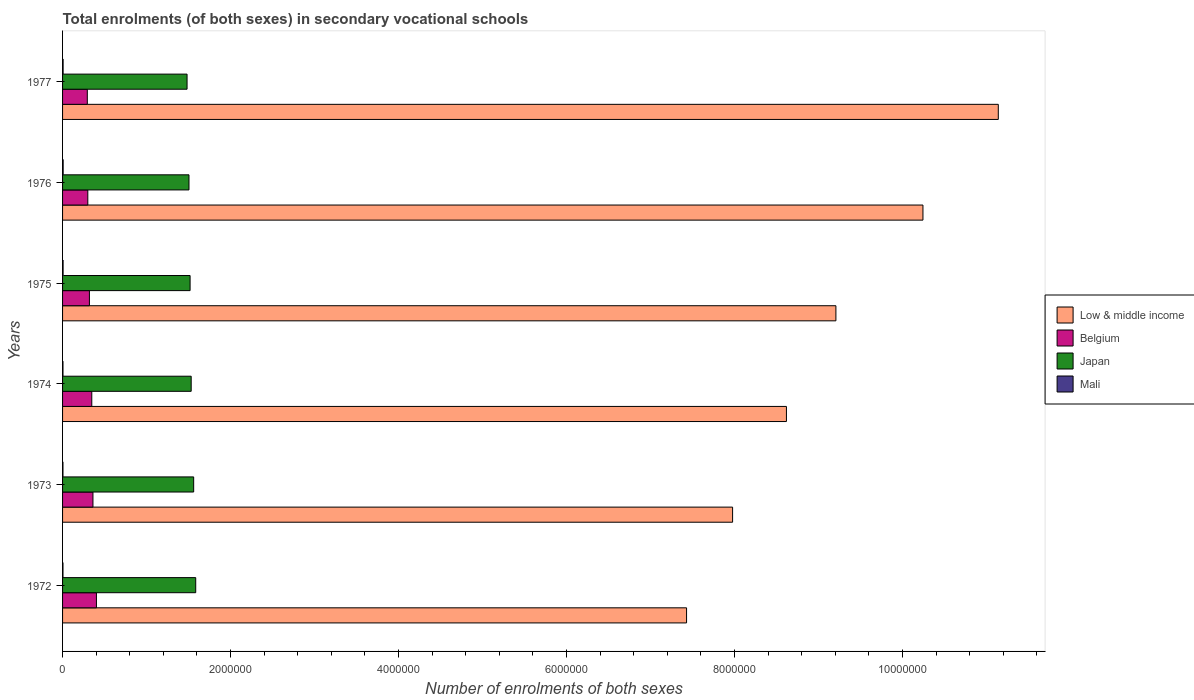How many different coloured bars are there?
Your answer should be very brief. 4. How many groups of bars are there?
Make the answer very short. 6. Are the number of bars per tick equal to the number of legend labels?
Offer a very short reply. Yes. How many bars are there on the 2nd tick from the bottom?
Provide a short and direct response. 4. What is the label of the 1st group of bars from the top?
Ensure brevity in your answer.  1977. In how many cases, is the number of bars for a given year not equal to the number of legend labels?
Ensure brevity in your answer.  0. What is the number of enrolments in secondary schools in Belgium in 1976?
Provide a succinct answer. 3.01e+05. Across all years, what is the maximum number of enrolments in secondary schools in Low & middle income?
Provide a succinct answer. 1.11e+07. Across all years, what is the minimum number of enrolments in secondary schools in Mali?
Make the answer very short. 4811. In which year was the number of enrolments in secondary schools in Low & middle income minimum?
Provide a short and direct response. 1972. What is the total number of enrolments in secondary schools in Low & middle income in the graph?
Make the answer very short. 5.46e+07. What is the difference between the number of enrolments in secondary schools in Mali in 1972 and that in 1973?
Your answer should be compact. 201. What is the difference between the number of enrolments in secondary schools in Mali in 1975 and the number of enrolments in secondary schools in Low & middle income in 1976?
Make the answer very short. -1.02e+07. What is the average number of enrolments in secondary schools in Belgium per year?
Provide a succinct answer. 3.38e+05. In the year 1972, what is the difference between the number of enrolments in secondary schools in Belgium and number of enrolments in secondary schools in Mali?
Offer a terse response. 3.98e+05. In how many years, is the number of enrolments in secondary schools in Japan greater than 9200000 ?
Give a very brief answer. 0. What is the ratio of the number of enrolments in secondary schools in Japan in 1972 to that in 1977?
Your answer should be compact. 1.07. Is the number of enrolments in secondary schools in Belgium in 1972 less than that in 1977?
Ensure brevity in your answer.  No. What is the difference between the highest and the second highest number of enrolments in secondary schools in Belgium?
Make the answer very short. 4.15e+04. What is the difference between the highest and the lowest number of enrolments in secondary schools in Low & middle income?
Your answer should be compact. 3.71e+06. Is the sum of the number of enrolments in secondary schools in Japan in 1975 and 1976 greater than the maximum number of enrolments in secondary schools in Low & middle income across all years?
Your response must be concise. No. What does the 1st bar from the top in 1972 represents?
Provide a short and direct response. Mali. Are all the bars in the graph horizontal?
Your response must be concise. Yes. What is the difference between two consecutive major ticks on the X-axis?
Keep it short and to the point. 2.00e+06. Are the values on the major ticks of X-axis written in scientific E-notation?
Give a very brief answer. No. Does the graph contain grids?
Offer a terse response. No. What is the title of the graph?
Make the answer very short. Total enrolments (of both sexes) in secondary vocational schools. Does "Mali" appear as one of the legend labels in the graph?
Provide a succinct answer. Yes. What is the label or title of the X-axis?
Ensure brevity in your answer.  Number of enrolments of both sexes. What is the Number of enrolments of both sexes of Low & middle income in 1972?
Your response must be concise. 7.43e+06. What is the Number of enrolments of both sexes of Belgium in 1972?
Ensure brevity in your answer.  4.03e+05. What is the Number of enrolments of both sexes in Japan in 1972?
Offer a very short reply. 1.59e+06. What is the Number of enrolments of both sexes of Mali in 1972?
Keep it short and to the point. 5012. What is the Number of enrolments of both sexes of Low & middle income in 1973?
Your answer should be very brief. 7.98e+06. What is the Number of enrolments of both sexes of Belgium in 1973?
Your answer should be very brief. 3.62e+05. What is the Number of enrolments of both sexes of Japan in 1973?
Your answer should be very brief. 1.56e+06. What is the Number of enrolments of both sexes of Mali in 1973?
Your answer should be compact. 4811. What is the Number of enrolments of both sexes in Low & middle income in 1974?
Your answer should be compact. 8.62e+06. What is the Number of enrolments of both sexes in Belgium in 1974?
Offer a very short reply. 3.48e+05. What is the Number of enrolments of both sexes in Japan in 1974?
Your response must be concise. 1.53e+06. What is the Number of enrolments of both sexes of Mali in 1974?
Your response must be concise. 4930. What is the Number of enrolments of both sexes of Low & middle income in 1975?
Provide a short and direct response. 9.21e+06. What is the Number of enrolments of both sexes in Belgium in 1975?
Make the answer very short. 3.20e+05. What is the Number of enrolments of both sexes of Japan in 1975?
Your response must be concise. 1.52e+06. What is the Number of enrolments of both sexes of Mali in 1975?
Your answer should be compact. 6366. What is the Number of enrolments of both sexes in Low & middle income in 1976?
Provide a short and direct response. 1.02e+07. What is the Number of enrolments of both sexes of Belgium in 1976?
Your response must be concise. 3.01e+05. What is the Number of enrolments of both sexes in Japan in 1976?
Provide a short and direct response. 1.51e+06. What is the Number of enrolments of both sexes of Mali in 1976?
Provide a succinct answer. 6956. What is the Number of enrolments of both sexes of Low & middle income in 1977?
Ensure brevity in your answer.  1.11e+07. What is the Number of enrolments of both sexes of Belgium in 1977?
Your answer should be very brief. 2.95e+05. What is the Number of enrolments of both sexes of Japan in 1977?
Your answer should be very brief. 1.48e+06. What is the Number of enrolments of both sexes in Mali in 1977?
Your response must be concise. 6514. Across all years, what is the maximum Number of enrolments of both sexes of Low & middle income?
Your answer should be very brief. 1.11e+07. Across all years, what is the maximum Number of enrolments of both sexes of Belgium?
Provide a succinct answer. 4.03e+05. Across all years, what is the maximum Number of enrolments of both sexes in Japan?
Your response must be concise. 1.59e+06. Across all years, what is the maximum Number of enrolments of both sexes in Mali?
Ensure brevity in your answer.  6956. Across all years, what is the minimum Number of enrolments of both sexes in Low & middle income?
Provide a succinct answer. 7.43e+06. Across all years, what is the minimum Number of enrolments of both sexes in Belgium?
Offer a very short reply. 2.95e+05. Across all years, what is the minimum Number of enrolments of both sexes of Japan?
Make the answer very short. 1.48e+06. Across all years, what is the minimum Number of enrolments of both sexes in Mali?
Offer a very short reply. 4811. What is the total Number of enrolments of both sexes of Low & middle income in the graph?
Offer a terse response. 5.46e+07. What is the total Number of enrolments of both sexes of Belgium in the graph?
Offer a very short reply. 2.03e+06. What is the total Number of enrolments of both sexes of Japan in the graph?
Give a very brief answer. 9.18e+06. What is the total Number of enrolments of both sexes of Mali in the graph?
Ensure brevity in your answer.  3.46e+04. What is the difference between the Number of enrolments of both sexes in Low & middle income in 1972 and that in 1973?
Offer a very short reply. -5.48e+05. What is the difference between the Number of enrolments of both sexes in Belgium in 1972 and that in 1973?
Provide a short and direct response. 4.15e+04. What is the difference between the Number of enrolments of both sexes of Japan in 1972 and that in 1973?
Offer a very short reply. 2.44e+04. What is the difference between the Number of enrolments of both sexes in Mali in 1972 and that in 1973?
Offer a terse response. 201. What is the difference between the Number of enrolments of both sexes of Low & middle income in 1972 and that in 1974?
Make the answer very short. -1.19e+06. What is the difference between the Number of enrolments of both sexes in Belgium in 1972 and that in 1974?
Your answer should be compact. 5.54e+04. What is the difference between the Number of enrolments of both sexes of Japan in 1972 and that in 1974?
Keep it short and to the point. 5.41e+04. What is the difference between the Number of enrolments of both sexes of Mali in 1972 and that in 1974?
Provide a succinct answer. 82. What is the difference between the Number of enrolments of both sexes in Low & middle income in 1972 and that in 1975?
Your answer should be very brief. -1.78e+06. What is the difference between the Number of enrolments of both sexes in Belgium in 1972 and that in 1975?
Give a very brief answer. 8.36e+04. What is the difference between the Number of enrolments of both sexes in Japan in 1972 and that in 1975?
Ensure brevity in your answer.  6.70e+04. What is the difference between the Number of enrolments of both sexes in Mali in 1972 and that in 1975?
Ensure brevity in your answer.  -1354. What is the difference between the Number of enrolments of both sexes in Low & middle income in 1972 and that in 1976?
Provide a short and direct response. -2.81e+06. What is the difference between the Number of enrolments of both sexes in Belgium in 1972 and that in 1976?
Your answer should be very brief. 1.03e+05. What is the difference between the Number of enrolments of both sexes of Japan in 1972 and that in 1976?
Offer a very short reply. 8.02e+04. What is the difference between the Number of enrolments of both sexes in Mali in 1972 and that in 1976?
Keep it short and to the point. -1944. What is the difference between the Number of enrolments of both sexes of Low & middle income in 1972 and that in 1977?
Your answer should be very brief. -3.71e+06. What is the difference between the Number of enrolments of both sexes of Belgium in 1972 and that in 1977?
Ensure brevity in your answer.  1.09e+05. What is the difference between the Number of enrolments of both sexes in Japan in 1972 and that in 1977?
Make the answer very short. 1.03e+05. What is the difference between the Number of enrolments of both sexes in Mali in 1972 and that in 1977?
Ensure brevity in your answer.  -1502. What is the difference between the Number of enrolments of both sexes of Low & middle income in 1973 and that in 1974?
Keep it short and to the point. -6.41e+05. What is the difference between the Number of enrolments of both sexes in Belgium in 1973 and that in 1974?
Keep it short and to the point. 1.40e+04. What is the difference between the Number of enrolments of both sexes in Japan in 1973 and that in 1974?
Ensure brevity in your answer.  2.97e+04. What is the difference between the Number of enrolments of both sexes of Mali in 1973 and that in 1974?
Your answer should be compact. -119. What is the difference between the Number of enrolments of both sexes of Low & middle income in 1973 and that in 1975?
Offer a terse response. -1.23e+06. What is the difference between the Number of enrolments of both sexes of Belgium in 1973 and that in 1975?
Offer a terse response. 4.21e+04. What is the difference between the Number of enrolments of both sexes of Japan in 1973 and that in 1975?
Offer a terse response. 4.26e+04. What is the difference between the Number of enrolments of both sexes of Mali in 1973 and that in 1975?
Provide a short and direct response. -1555. What is the difference between the Number of enrolments of both sexes of Low & middle income in 1973 and that in 1976?
Ensure brevity in your answer.  -2.27e+06. What is the difference between the Number of enrolments of both sexes of Belgium in 1973 and that in 1976?
Offer a very short reply. 6.13e+04. What is the difference between the Number of enrolments of both sexes in Japan in 1973 and that in 1976?
Provide a succinct answer. 5.59e+04. What is the difference between the Number of enrolments of both sexes in Mali in 1973 and that in 1976?
Ensure brevity in your answer.  -2145. What is the difference between the Number of enrolments of both sexes of Low & middle income in 1973 and that in 1977?
Ensure brevity in your answer.  -3.16e+06. What is the difference between the Number of enrolments of both sexes in Belgium in 1973 and that in 1977?
Provide a short and direct response. 6.72e+04. What is the difference between the Number of enrolments of both sexes in Japan in 1973 and that in 1977?
Offer a terse response. 7.88e+04. What is the difference between the Number of enrolments of both sexes of Mali in 1973 and that in 1977?
Ensure brevity in your answer.  -1703. What is the difference between the Number of enrolments of both sexes of Low & middle income in 1974 and that in 1975?
Your answer should be compact. -5.89e+05. What is the difference between the Number of enrolments of both sexes of Belgium in 1974 and that in 1975?
Ensure brevity in your answer.  2.81e+04. What is the difference between the Number of enrolments of both sexes of Japan in 1974 and that in 1975?
Give a very brief answer. 1.29e+04. What is the difference between the Number of enrolments of both sexes of Mali in 1974 and that in 1975?
Keep it short and to the point. -1436. What is the difference between the Number of enrolments of both sexes in Low & middle income in 1974 and that in 1976?
Ensure brevity in your answer.  -1.63e+06. What is the difference between the Number of enrolments of both sexes in Belgium in 1974 and that in 1976?
Give a very brief answer. 4.73e+04. What is the difference between the Number of enrolments of both sexes in Japan in 1974 and that in 1976?
Offer a very short reply. 2.62e+04. What is the difference between the Number of enrolments of both sexes in Mali in 1974 and that in 1976?
Ensure brevity in your answer.  -2026. What is the difference between the Number of enrolments of both sexes in Low & middle income in 1974 and that in 1977?
Make the answer very short. -2.52e+06. What is the difference between the Number of enrolments of both sexes of Belgium in 1974 and that in 1977?
Your answer should be compact. 5.32e+04. What is the difference between the Number of enrolments of both sexes of Japan in 1974 and that in 1977?
Keep it short and to the point. 4.91e+04. What is the difference between the Number of enrolments of both sexes of Mali in 1974 and that in 1977?
Ensure brevity in your answer.  -1584. What is the difference between the Number of enrolments of both sexes of Low & middle income in 1975 and that in 1976?
Ensure brevity in your answer.  -1.04e+06. What is the difference between the Number of enrolments of both sexes in Belgium in 1975 and that in 1976?
Give a very brief answer. 1.92e+04. What is the difference between the Number of enrolments of both sexes in Japan in 1975 and that in 1976?
Offer a terse response. 1.33e+04. What is the difference between the Number of enrolments of both sexes in Mali in 1975 and that in 1976?
Keep it short and to the point. -590. What is the difference between the Number of enrolments of both sexes of Low & middle income in 1975 and that in 1977?
Ensure brevity in your answer.  -1.93e+06. What is the difference between the Number of enrolments of both sexes in Belgium in 1975 and that in 1977?
Your response must be concise. 2.51e+04. What is the difference between the Number of enrolments of both sexes of Japan in 1975 and that in 1977?
Your answer should be compact. 3.62e+04. What is the difference between the Number of enrolments of both sexes in Mali in 1975 and that in 1977?
Offer a very short reply. -148. What is the difference between the Number of enrolments of both sexes of Low & middle income in 1976 and that in 1977?
Ensure brevity in your answer.  -8.97e+05. What is the difference between the Number of enrolments of both sexes of Belgium in 1976 and that in 1977?
Provide a succinct answer. 5933. What is the difference between the Number of enrolments of both sexes of Japan in 1976 and that in 1977?
Provide a short and direct response. 2.29e+04. What is the difference between the Number of enrolments of both sexes in Mali in 1976 and that in 1977?
Your answer should be compact. 442. What is the difference between the Number of enrolments of both sexes of Low & middle income in 1972 and the Number of enrolments of both sexes of Belgium in 1973?
Your response must be concise. 7.07e+06. What is the difference between the Number of enrolments of both sexes in Low & middle income in 1972 and the Number of enrolments of both sexes in Japan in 1973?
Offer a terse response. 5.87e+06. What is the difference between the Number of enrolments of both sexes of Low & middle income in 1972 and the Number of enrolments of both sexes of Mali in 1973?
Keep it short and to the point. 7.42e+06. What is the difference between the Number of enrolments of both sexes in Belgium in 1972 and the Number of enrolments of both sexes in Japan in 1973?
Offer a terse response. -1.16e+06. What is the difference between the Number of enrolments of both sexes in Belgium in 1972 and the Number of enrolments of both sexes in Mali in 1973?
Give a very brief answer. 3.98e+05. What is the difference between the Number of enrolments of both sexes of Japan in 1972 and the Number of enrolments of both sexes of Mali in 1973?
Your answer should be very brief. 1.58e+06. What is the difference between the Number of enrolments of both sexes in Low & middle income in 1972 and the Number of enrolments of both sexes in Belgium in 1974?
Keep it short and to the point. 7.08e+06. What is the difference between the Number of enrolments of both sexes of Low & middle income in 1972 and the Number of enrolments of both sexes of Japan in 1974?
Offer a very short reply. 5.90e+06. What is the difference between the Number of enrolments of both sexes of Low & middle income in 1972 and the Number of enrolments of both sexes of Mali in 1974?
Your answer should be very brief. 7.42e+06. What is the difference between the Number of enrolments of both sexes of Belgium in 1972 and the Number of enrolments of both sexes of Japan in 1974?
Provide a short and direct response. -1.13e+06. What is the difference between the Number of enrolments of both sexes in Belgium in 1972 and the Number of enrolments of both sexes in Mali in 1974?
Your response must be concise. 3.98e+05. What is the difference between the Number of enrolments of both sexes in Japan in 1972 and the Number of enrolments of both sexes in Mali in 1974?
Your answer should be very brief. 1.58e+06. What is the difference between the Number of enrolments of both sexes of Low & middle income in 1972 and the Number of enrolments of both sexes of Belgium in 1975?
Provide a succinct answer. 7.11e+06. What is the difference between the Number of enrolments of both sexes in Low & middle income in 1972 and the Number of enrolments of both sexes in Japan in 1975?
Ensure brevity in your answer.  5.91e+06. What is the difference between the Number of enrolments of both sexes in Low & middle income in 1972 and the Number of enrolments of both sexes in Mali in 1975?
Give a very brief answer. 7.42e+06. What is the difference between the Number of enrolments of both sexes in Belgium in 1972 and the Number of enrolments of both sexes in Japan in 1975?
Ensure brevity in your answer.  -1.12e+06. What is the difference between the Number of enrolments of both sexes in Belgium in 1972 and the Number of enrolments of both sexes in Mali in 1975?
Provide a succinct answer. 3.97e+05. What is the difference between the Number of enrolments of both sexes in Japan in 1972 and the Number of enrolments of both sexes in Mali in 1975?
Ensure brevity in your answer.  1.58e+06. What is the difference between the Number of enrolments of both sexes of Low & middle income in 1972 and the Number of enrolments of both sexes of Belgium in 1976?
Offer a terse response. 7.13e+06. What is the difference between the Number of enrolments of both sexes in Low & middle income in 1972 and the Number of enrolments of both sexes in Japan in 1976?
Keep it short and to the point. 5.92e+06. What is the difference between the Number of enrolments of both sexes of Low & middle income in 1972 and the Number of enrolments of both sexes of Mali in 1976?
Your answer should be compact. 7.42e+06. What is the difference between the Number of enrolments of both sexes in Belgium in 1972 and the Number of enrolments of both sexes in Japan in 1976?
Give a very brief answer. -1.10e+06. What is the difference between the Number of enrolments of both sexes of Belgium in 1972 and the Number of enrolments of both sexes of Mali in 1976?
Make the answer very short. 3.96e+05. What is the difference between the Number of enrolments of both sexes in Japan in 1972 and the Number of enrolments of both sexes in Mali in 1976?
Offer a very short reply. 1.58e+06. What is the difference between the Number of enrolments of both sexes of Low & middle income in 1972 and the Number of enrolments of both sexes of Belgium in 1977?
Your answer should be compact. 7.13e+06. What is the difference between the Number of enrolments of both sexes of Low & middle income in 1972 and the Number of enrolments of both sexes of Japan in 1977?
Keep it short and to the point. 5.95e+06. What is the difference between the Number of enrolments of both sexes of Low & middle income in 1972 and the Number of enrolments of both sexes of Mali in 1977?
Ensure brevity in your answer.  7.42e+06. What is the difference between the Number of enrolments of both sexes in Belgium in 1972 and the Number of enrolments of both sexes in Japan in 1977?
Ensure brevity in your answer.  -1.08e+06. What is the difference between the Number of enrolments of both sexes in Belgium in 1972 and the Number of enrolments of both sexes in Mali in 1977?
Make the answer very short. 3.97e+05. What is the difference between the Number of enrolments of both sexes of Japan in 1972 and the Number of enrolments of both sexes of Mali in 1977?
Keep it short and to the point. 1.58e+06. What is the difference between the Number of enrolments of both sexes of Low & middle income in 1973 and the Number of enrolments of both sexes of Belgium in 1974?
Your response must be concise. 7.63e+06. What is the difference between the Number of enrolments of both sexes in Low & middle income in 1973 and the Number of enrolments of both sexes in Japan in 1974?
Provide a succinct answer. 6.45e+06. What is the difference between the Number of enrolments of both sexes in Low & middle income in 1973 and the Number of enrolments of both sexes in Mali in 1974?
Your answer should be very brief. 7.97e+06. What is the difference between the Number of enrolments of both sexes of Belgium in 1973 and the Number of enrolments of both sexes of Japan in 1974?
Your answer should be very brief. -1.17e+06. What is the difference between the Number of enrolments of both sexes of Belgium in 1973 and the Number of enrolments of both sexes of Mali in 1974?
Offer a terse response. 3.57e+05. What is the difference between the Number of enrolments of both sexes of Japan in 1973 and the Number of enrolments of both sexes of Mali in 1974?
Keep it short and to the point. 1.56e+06. What is the difference between the Number of enrolments of both sexes in Low & middle income in 1973 and the Number of enrolments of both sexes in Belgium in 1975?
Offer a very short reply. 7.66e+06. What is the difference between the Number of enrolments of both sexes in Low & middle income in 1973 and the Number of enrolments of both sexes in Japan in 1975?
Your response must be concise. 6.46e+06. What is the difference between the Number of enrolments of both sexes of Low & middle income in 1973 and the Number of enrolments of both sexes of Mali in 1975?
Your answer should be very brief. 7.97e+06. What is the difference between the Number of enrolments of both sexes of Belgium in 1973 and the Number of enrolments of both sexes of Japan in 1975?
Give a very brief answer. -1.16e+06. What is the difference between the Number of enrolments of both sexes of Belgium in 1973 and the Number of enrolments of both sexes of Mali in 1975?
Offer a very short reply. 3.55e+05. What is the difference between the Number of enrolments of both sexes of Japan in 1973 and the Number of enrolments of both sexes of Mali in 1975?
Your answer should be compact. 1.55e+06. What is the difference between the Number of enrolments of both sexes in Low & middle income in 1973 and the Number of enrolments of both sexes in Belgium in 1976?
Offer a terse response. 7.68e+06. What is the difference between the Number of enrolments of both sexes of Low & middle income in 1973 and the Number of enrolments of both sexes of Japan in 1976?
Offer a very short reply. 6.47e+06. What is the difference between the Number of enrolments of both sexes in Low & middle income in 1973 and the Number of enrolments of both sexes in Mali in 1976?
Provide a short and direct response. 7.97e+06. What is the difference between the Number of enrolments of both sexes of Belgium in 1973 and the Number of enrolments of both sexes of Japan in 1976?
Give a very brief answer. -1.14e+06. What is the difference between the Number of enrolments of both sexes in Belgium in 1973 and the Number of enrolments of both sexes in Mali in 1976?
Offer a terse response. 3.55e+05. What is the difference between the Number of enrolments of both sexes in Japan in 1973 and the Number of enrolments of both sexes in Mali in 1976?
Offer a very short reply. 1.55e+06. What is the difference between the Number of enrolments of both sexes of Low & middle income in 1973 and the Number of enrolments of both sexes of Belgium in 1977?
Provide a short and direct response. 7.68e+06. What is the difference between the Number of enrolments of both sexes of Low & middle income in 1973 and the Number of enrolments of both sexes of Japan in 1977?
Ensure brevity in your answer.  6.49e+06. What is the difference between the Number of enrolments of both sexes in Low & middle income in 1973 and the Number of enrolments of both sexes in Mali in 1977?
Offer a very short reply. 7.97e+06. What is the difference between the Number of enrolments of both sexes of Belgium in 1973 and the Number of enrolments of both sexes of Japan in 1977?
Keep it short and to the point. -1.12e+06. What is the difference between the Number of enrolments of both sexes in Belgium in 1973 and the Number of enrolments of both sexes in Mali in 1977?
Offer a terse response. 3.55e+05. What is the difference between the Number of enrolments of both sexes in Japan in 1973 and the Number of enrolments of both sexes in Mali in 1977?
Provide a short and direct response. 1.55e+06. What is the difference between the Number of enrolments of both sexes in Low & middle income in 1974 and the Number of enrolments of both sexes in Belgium in 1975?
Provide a succinct answer. 8.30e+06. What is the difference between the Number of enrolments of both sexes in Low & middle income in 1974 and the Number of enrolments of both sexes in Japan in 1975?
Offer a very short reply. 7.10e+06. What is the difference between the Number of enrolments of both sexes of Low & middle income in 1974 and the Number of enrolments of both sexes of Mali in 1975?
Your response must be concise. 8.61e+06. What is the difference between the Number of enrolments of both sexes in Belgium in 1974 and the Number of enrolments of both sexes in Japan in 1975?
Make the answer very short. -1.17e+06. What is the difference between the Number of enrolments of both sexes of Belgium in 1974 and the Number of enrolments of both sexes of Mali in 1975?
Your response must be concise. 3.41e+05. What is the difference between the Number of enrolments of both sexes of Japan in 1974 and the Number of enrolments of both sexes of Mali in 1975?
Give a very brief answer. 1.52e+06. What is the difference between the Number of enrolments of both sexes in Low & middle income in 1974 and the Number of enrolments of both sexes in Belgium in 1976?
Provide a short and direct response. 8.32e+06. What is the difference between the Number of enrolments of both sexes of Low & middle income in 1974 and the Number of enrolments of both sexes of Japan in 1976?
Your answer should be compact. 7.11e+06. What is the difference between the Number of enrolments of both sexes of Low & middle income in 1974 and the Number of enrolments of both sexes of Mali in 1976?
Make the answer very short. 8.61e+06. What is the difference between the Number of enrolments of both sexes in Belgium in 1974 and the Number of enrolments of both sexes in Japan in 1976?
Your answer should be very brief. -1.16e+06. What is the difference between the Number of enrolments of both sexes of Belgium in 1974 and the Number of enrolments of both sexes of Mali in 1976?
Keep it short and to the point. 3.41e+05. What is the difference between the Number of enrolments of both sexes in Japan in 1974 and the Number of enrolments of both sexes in Mali in 1976?
Offer a very short reply. 1.52e+06. What is the difference between the Number of enrolments of both sexes of Low & middle income in 1974 and the Number of enrolments of both sexes of Belgium in 1977?
Make the answer very short. 8.32e+06. What is the difference between the Number of enrolments of both sexes in Low & middle income in 1974 and the Number of enrolments of both sexes in Japan in 1977?
Ensure brevity in your answer.  7.14e+06. What is the difference between the Number of enrolments of both sexes of Low & middle income in 1974 and the Number of enrolments of both sexes of Mali in 1977?
Your answer should be compact. 8.61e+06. What is the difference between the Number of enrolments of both sexes of Belgium in 1974 and the Number of enrolments of both sexes of Japan in 1977?
Your response must be concise. -1.13e+06. What is the difference between the Number of enrolments of both sexes in Belgium in 1974 and the Number of enrolments of both sexes in Mali in 1977?
Your answer should be compact. 3.41e+05. What is the difference between the Number of enrolments of both sexes of Japan in 1974 and the Number of enrolments of both sexes of Mali in 1977?
Offer a terse response. 1.52e+06. What is the difference between the Number of enrolments of both sexes in Low & middle income in 1975 and the Number of enrolments of both sexes in Belgium in 1976?
Offer a very short reply. 8.91e+06. What is the difference between the Number of enrolments of both sexes of Low & middle income in 1975 and the Number of enrolments of both sexes of Japan in 1976?
Ensure brevity in your answer.  7.70e+06. What is the difference between the Number of enrolments of both sexes in Low & middle income in 1975 and the Number of enrolments of both sexes in Mali in 1976?
Give a very brief answer. 9.20e+06. What is the difference between the Number of enrolments of both sexes in Belgium in 1975 and the Number of enrolments of both sexes in Japan in 1976?
Provide a succinct answer. -1.19e+06. What is the difference between the Number of enrolments of both sexes in Belgium in 1975 and the Number of enrolments of both sexes in Mali in 1976?
Provide a succinct answer. 3.13e+05. What is the difference between the Number of enrolments of both sexes of Japan in 1975 and the Number of enrolments of both sexes of Mali in 1976?
Keep it short and to the point. 1.51e+06. What is the difference between the Number of enrolments of both sexes in Low & middle income in 1975 and the Number of enrolments of both sexes in Belgium in 1977?
Provide a short and direct response. 8.91e+06. What is the difference between the Number of enrolments of both sexes of Low & middle income in 1975 and the Number of enrolments of both sexes of Japan in 1977?
Keep it short and to the point. 7.72e+06. What is the difference between the Number of enrolments of both sexes of Low & middle income in 1975 and the Number of enrolments of both sexes of Mali in 1977?
Give a very brief answer. 9.20e+06. What is the difference between the Number of enrolments of both sexes in Belgium in 1975 and the Number of enrolments of both sexes in Japan in 1977?
Provide a succinct answer. -1.16e+06. What is the difference between the Number of enrolments of both sexes of Belgium in 1975 and the Number of enrolments of both sexes of Mali in 1977?
Your response must be concise. 3.13e+05. What is the difference between the Number of enrolments of both sexes in Japan in 1975 and the Number of enrolments of both sexes in Mali in 1977?
Provide a succinct answer. 1.51e+06. What is the difference between the Number of enrolments of both sexes of Low & middle income in 1976 and the Number of enrolments of both sexes of Belgium in 1977?
Provide a succinct answer. 9.95e+06. What is the difference between the Number of enrolments of both sexes in Low & middle income in 1976 and the Number of enrolments of both sexes in Japan in 1977?
Offer a terse response. 8.76e+06. What is the difference between the Number of enrolments of both sexes of Low & middle income in 1976 and the Number of enrolments of both sexes of Mali in 1977?
Offer a very short reply. 1.02e+07. What is the difference between the Number of enrolments of both sexes in Belgium in 1976 and the Number of enrolments of both sexes in Japan in 1977?
Keep it short and to the point. -1.18e+06. What is the difference between the Number of enrolments of both sexes in Belgium in 1976 and the Number of enrolments of both sexes in Mali in 1977?
Keep it short and to the point. 2.94e+05. What is the difference between the Number of enrolments of both sexes in Japan in 1976 and the Number of enrolments of both sexes in Mali in 1977?
Offer a terse response. 1.50e+06. What is the average Number of enrolments of both sexes in Low & middle income per year?
Offer a terse response. 9.10e+06. What is the average Number of enrolments of both sexes of Belgium per year?
Ensure brevity in your answer.  3.38e+05. What is the average Number of enrolments of both sexes in Japan per year?
Give a very brief answer. 1.53e+06. What is the average Number of enrolments of both sexes in Mali per year?
Your answer should be compact. 5764.83. In the year 1972, what is the difference between the Number of enrolments of both sexes in Low & middle income and Number of enrolments of both sexes in Belgium?
Offer a very short reply. 7.03e+06. In the year 1972, what is the difference between the Number of enrolments of both sexes in Low & middle income and Number of enrolments of both sexes in Japan?
Offer a terse response. 5.84e+06. In the year 1972, what is the difference between the Number of enrolments of both sexes of Low & middle income and Number of enrolments of both sexes of Mali?
Keep it short and to the point. 7.42e+06. In the year 1972, what is the difference between the Number of enrolments of both sexes of Belgium and Number of enrolments of both sexes of Japan?
Keep it short and to the point. -1.18e+06. In the year 1972, what is the difference between the Number of enrolments of both sexes in Belgium and Number of enrolments of both sexes in Mali?
Keep it short and to the point. 3.98e+05. In the year 1972, what is the difference between the Number of enrolments of both sexes in Japan and Number of enrolments of both sexes in Mali?
Offer a terse response. 1.58e+06. In the year 1973, what is the difference between the Number of enrolments of both sexes of Low & middle income and Number of enrolments of both sexes of Belgium?
Provide a short and direct response. 7.61e+06. In the year 1973, what is the difference between the Number of enrolments of both sexes of Low & middle income and Number of enrolments of both sexes of Japan?
Provide a short and direct response. 6.42e+06. In the year 1973, what is the difference between the Number of enrolments of both sexes of Low & middle income and Number of enrolments of both sexes of Mali?
Provide a succinct answer. 7.97e+06. In the year 1973, what is the difference between the Number of enrolments of both sexes of Belgium and Number of enrolments of both sexes of Japan?
Keep it short and to the point. -1.20e+06. In the year 1973, what is the difference between the Number of enrolments of both sexes in Belgium and Number of enrolments of both sexes in Mali?
Make the answer very short. 3.57e+05. In the year 1973, what is the difference between the Number of enrolments of both sexes in Japan and Number of enrolments of both sexes in Mali?
Your answer should be very brief. 1.56e+06. In the year 1974, what is the difference between the Number of enrolments of both sexes in Low & middle income and Number of enrolments of both sexes in Belgium?
Give a very brief answer. 8.27e+06. In the year 1974, what is the difference between the Number of enrolments of both sexes of Low & middle income and Number of enrolments of both sexes of Japan?
Provide a short and direct response. 7.09e+06. In the year 1974, what is the difference between the Number of enrolments of both sexes of Low & middle income and Number of enrolments of both sexes of Mali?
Your response must be concise. 8.61e+06. In the year 1974, what is the difference between the Number of enrolments of both sexes of Belgium and Number of enrolments of both sexes of Japan?
Keep it short and to the point. -1.18e+06. In the year 1974, what is the difference between the Number of enrolments of both sexes in Belgium and Number of enrolments of both sexes in Mali?
Your answer should be compact. 3.43e+05. In the year 1974, what is the difference between the Number of enrolments of both sexes in Japan and Number of enrolments of both sexes in Mali?
Keep it short and to the point. 1.53e+06. In the year 1975, what is the difference between the Number of enrolments of both sexes in Low & middle income and Number of enrolments of both sexes in Belgium?
Your answer should be very brief. 8.89e+06. In the year 1975, what is the difference between the Number of enrolments of both sexes in Low & middle income and Number of enrolments of both sexes in Japan?
Provide a short and direct response. 7.69e+06. In the year 1975, what is the difference between the Number of enrolments of both sexes in Low & middle income and Number of enrolments of both sexes in Mali?
Your answer should be very brief. 9.20e+06. In the year 1975, what is the difference between the Number of enrolments of both sexes of Belgium and Number of enrolments of both sexes of Japan?
Your response must be concise. -1.20e+06. In the year 1975, what is the difference between the Number of enrolments of both sexes in Belgium and Number of enrolments of both sexes in Mali?
Your answer should be compact. 3.13e+05. In the year 1975, what is the difference between the Number of enrolments of both sexes of Japan and Number of enrolments of both sexes of Mali?
Your answer should be compact. 1.51e+06. In the year 1976, what is the difference between the Number of enrolments of both sexes of Low & middle income and Number of enrolments of both sexes of Belgium?
Keep it short and to the point. 9.94e+06. In the year 1976, what is the difference between the Number of enrolments of both sexes in Low & middle income and Number of enrolments of both sexes in Japan?
Offer a terse response. 8.74e+06. In the year 1976, what is the difference between the Number of enrolments of both sexes in Low & middle income and Number of enrolments of both sexes in Mali?
Provide a succinct answer. 1.02e+07. In the year 1976, what is the difference between the Number of enrolments of both sexes in Belgium and Number of enrolments of both sexes in Japan?
Your answer should be compact. -1.20e+06. In the year 1976, what is the difference between the Number of enrolments of both sexes in Belgium and Number of enrolments of both sexes in Mali?
Your response must be concise. 2.94e+05. In the year 1976, what is the difference between the Number of enrolments of both sexes in Japan and Number of enrolments of both sexes in Mali?
Offer a terse response. 1.50e+06. In the year 1977, what is the difference between the Number of enrolments of both sexes in Low & middle income and Number of enrolments of both sexes in Belgium?
Ensure brevity in your answer.  1.08e+07. In the year 1977, what is the difference between the Number of enrolments of both sexes of Low & middle income and Number of enrolments of both sexes of Japan?
Provide a short and direct response. 9.66e+06. In the year 1977, what is the difference between the Number of enrolments of both sexes of Low & middle income and Number of enrolments of both sexes of Mali?
Ensure brevity in your answer.  1.11e+07. In the year 1977, what is the difference between the Number of enrolments of both sexes in Belgium and Number of enrolments of both sexes in Japan?
Make the answer very short. -1.19e+06. In the year 1977, what is the difference between the Number of enrolments of both sexes in Belgium and Number of enrolments of both sexes in Mali?
Give a very brief answer. 2.88e+05. In the year 1977, what is the difference between the Number of enrolments of both sexes of Japan and Number of enrolments of both sexes of Mali?
Ensure brevity in your answer.  1.48e+06. What is the ratio of the Number of enrolments of both sexes of Low & middle income in 1972 to that in 1973?
Ensure brevity in your answer.  0.93. What is the ratio of the Number of enrolments of both sexes in Belgium in 1972 to that in 1973?
Your answer should be compact. 1.11. What is the ratio of the Number of enrolments of both sexes of Japan in 1972 to that in 1973?
Your answer should be very brief. 1.02. What is the ratio of the Number of enrolments of both sexes of Mali in 1972 to that in 1973?
Offer a very short reply. 1.04. What is the ratio of the Number of enrolments of both sexes of Low & middle income in 1972 to that in 1974?
Provide a succinct answer. 0.86. What is the ratio of the Number of enrolments of both sexes of Belgium in 1972 to that in 1974?
Your response must be concise. 1.16. What is the ratio of the Number of enrolments of both sexes of Japan in 1972 to that in 1974?
Your answer should be compact. 1.04. What is the ratio of the Number of enrolments of both sexes of Mali in 1972 to that in 1974?
Your response must be concise. 1.02. What is the ratio of the Number of enrolments of both sexes of Low & middle income in 1972 to that in 1975?
Give a very brief answer. 0.81. What is the ratio of the Number of enrolments of both sexes in Belgium in 1972 to that in 1975?
Your answer should be very brief. 1.26. What is the ratio of the Number of enrolments of both sexes in Japan in 1972 to that in 1975?
Your response must be concise. 1.04. What is the ratio of the Number of enrolments of both sexes of Mali in 1972 to that in 1975?
Offer a very short reply. 0.79. What is the ratio of the Number of enrolments of both sexes in Low & middle income in 1972 to that in 1976?
Give a very brief answer. 0.73. What is the ratio of the Number of enrolments of both sexes in Belgium in 1972 to that in 1976?
Ensure brevity in your answer.  1.34. What is the ratio of the Number of enrolments of both sexes in Japan in 1972 to that in 1976?
Keep it short and to the point. 1.05. What is the ratio of the Number of enrolments of both sexes of Mali in 1972 to that in 1976?
Offer a very short reply. 0.72. What is the ratio of the Number of enrolments of both sexes in Low & middle income in 1972 to that in 1977?
Ensure brevity in your answer.  0.67. What is the ratio of the Number of enrolments of both sexes of Belgium in 1972 to that in 1977?
Provide a succinct answer. 1.37. What is the ratio of the Number of enrolments of both sexes in Japan in 1972 to that in 1977?
Your answer should be compact. 1.07. What is the ratio of the Number of enrolments of both sexes in Mali in 1972 to that in 1977?
Offer a very short reply. 0.77. What is the ratio of the Number of enrolments of both sexes in Low & middle income in 1973 to that in 1974?
Keep it short and to the point. 0.93. What is the ratio of the Number of enrolments of both sexes in Belgium in 1973 to that in 1974?
Your answer should be compact. 1.04. What is the ratio of the Number of enrolments of both sexes of Japan in 1973 to that in 1974?
Offer a very short reply. 1.02. What is the ratio of the Number of enrolments of both sexes of Mali in 1973 to that in 1974?
Your answer should be very brief. 0.98. What is the ratio of the Number of enrolments of both sexes in Low & middle income in 1973 to that in 1975?
Offer a very short reply. 0.87. What is the ratio of the Number of enrolments of both sexes in Belgium in 1973 to that in 1975?
Your answer should be very brief. 1.13. What is the ratio of the Number of enrolments of both sexes in Japan in 1973 to that in 1975?
Offer a very short reply. 1.03. What is the ratio of the Number of enrolments of both sexes of Mali in 1973 to that in 1975?
Your answer should be very brief. 0.76. What is the ratio of the Number of enrolments of both sexes in Low & middle income in 1973 to that in 1976?
Keep it short and to the point. 0.78. What is the ratio of the Number of enrolments of both sexes in Belgium in 1973 to that in 1976?
Give a very brief answer. 1.2. What is the ratio of the Number of enrolments of both sexes of Japan in 1973 to that in 1976?
Provide a succinct answer. 1.04. What is the ratio of the Number of enrolments of both sexes of Mali in 1973 to that in 1976?
Your answer should be compact. 0.69. What is the ratio of the Number of enrolments of both sexes of Low & middle income in 1973 to that in 1977?
Offer a very short reply. 0.72. What is the ratio of the Number of enrolments of both sexes of Belgium in 1973 to that in 1977?
Your answer should be compact. 1.23. What is the ratio of the Number of enrolments of both sexes in Japan in 1973 to that in 1977?
Your answer should be compact. 1.05. What is the ratio of the Number of enrolments of both sexes in Mali in 1973 to that in 1977?
Provide a succinct answer. 0.74. What is the ratio of the Number of enrolments of both sexes in Low & middle income in 1974 to that in 1975?
Provide a succinct answer. 0.94. What is the ratio of the Number of enrolments of both sexes in Belgium in 1974 to that in 1975?
Your answer should be compact. 1.09. What is the ratio of the Number of enrolments of both sexes of Japan in 1974 to that in 1975?
Make the answer very short. 1.01. What is the ratio of the Number of enrolments of both sexes in Mali in 1974 to that in 1975?
Your answer should be very brief. 0.77. What is the ratio of the Number of enrolments of both sexes of Low & middle income in 1974 to that in 1976?
Keep it short and to the point. 0.84. What is the ratio of the Number of enrolments of both sexes in Belgium in 1974 to that in 1976?
Your response must be concise. 1.16. What is the ratio of the Number of enrolments of both sexes of Japan in 1974 to that in 1976?
Make the answer very short. 1.02. What is the ratio of the Number of enrolments of both sexes of Mali in 1974 to that in 1976?
Ensure brevity in your answer.  0.71. What is the ratio of the Number of enrolments of both sexes of Low & middle income in 1974 to that in 1977?
Ensure brevity in your answer.  0.77. What is the ratio of the Number of enrolments of both sexes of Belgium in 1974 to that in 1977?
Your answer should be compact. 1.18. What is the ratio of the Number of enrolments of both sexes of Japan in 1974 to that in 1977?
Offer a terse response. 1.03. What is the ratio of the Number of enrolments of both sexes in Mali in 1974 to that in 1977?
Provide a short and direct response. 0.76. What is the ratio of the Number of enrolments of both sexes in Low & middle income in 1975 to that in 1976?
Make the answer very short. 0.9. What is the ratio of the Number of enrolments of both sexes of Belgium in 1975 to that in 1976?
Ensure brevity in your answer.  1.06. What is the ratio of the Number of enrolments of both sexes of Japan in 1975 to that in 1976?
Offer a very short reply. 1.01. What is the ratio of the Number of enrolments of both sexes of Mali in 1975 to that in 1976?
Give a very brief answer. 0.92. What is the ratio of the Number of enrolments of both sexes in Low & middle income in 1975 to that in 1977?
Keep it short and to the point. 0.83. What is the ratio of the Number of enrolments of both sexes in Belgium in 1975 to that in 1977?
Keep it short and to the point. 1.09. What is the ratio of the Number of enrolments of both sexes of Japan in 1975 to that in 1977?
Offer a terse response. 1.02. What is the ratio of the Number of enrolments of both sexes in Mali in 1975 to that in 1977?
Your answer should be compact. 0.98. What is the ratio of the Number of enrolments of both sexes in Low & middle income in 1976 to that in 1977?
Give a very brief answer. 0.92. What is the ratio of the Number of enrolments of both sexes in Belgium in 1976 to that in 1977?
Your answer should be compact. 1.02. What is the ratio of the Number of enrolments of both sexes in Japan in 1976 to that in 1977?
Keep it short and to the point. 1.02. What is the ratio of the Number of enrolments of both sexes of Mali in 1976 to that in 1977?
Offer a terse response. 1.07. What is the difference between the highest and the second highest Number of enrolments of both sexes in Low & middle income?
Make the answer very short. 8.97e+05. What is the difference between the highest and the second highest Number of enrolments of both sexes of Belgium?
Provide a succinct answer. 4.15e+04. What is the difference between the highest and the second highest Number of enrolments of both sexes of Japan?
Provide a short and direct response. 2.44e+04. What is the difference between the highest and the second highest Number of enrolments of both sexes of Mali?
Your answer should be very brief. 442. What is the difference between the highest and the lowest Number of enrolments of both sexes in Low & middle income?
Provide a short and direct response. 3.71e+06. What is the difference between the highest and the lowest Number of enrolments of both sexes in Belgium?
Give a very brief answer. 1.09e+05. What is the difference between the highest and the lowest Number of enrolments of both sexes in Japan?
Ensure brevity in your answer.  1.03e+05. What is the difference between the highest and the lowest Number of enrolments of both sexes of Mali?
Make the answer very short. 2145. 